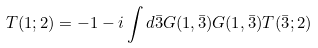<formula> <loc_0><loc_0><loc_500><loc_500>T ( 1 ; 2 ) = - 1 - i \int d { \bar { 3 } } G ( 1 , \bar { 3 } ) G ( 1 , \bar { 3 } ) T ( \bar { 3 } ; 2 )</formula> 